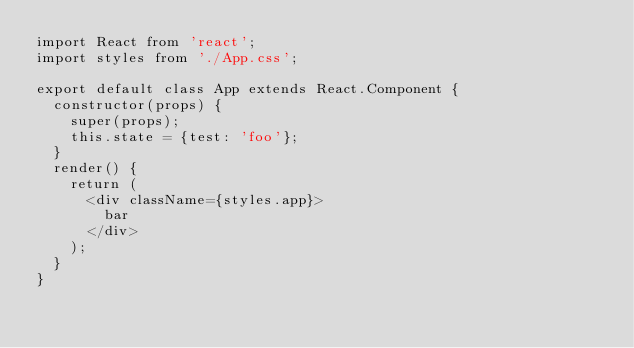<code> <loc_0><loc_0><loc_500><loc_500><_JavaScript_>import React from 'react';
import styles from './App.css';

export default class App extends React.Component {
  constructor(props) {
    super(props);
    this.state = {test: 'foo'};
  }
  render() {
    return (
      <div className={styles.app}>
        bar
      </div>
    );
  }
}
</code> 